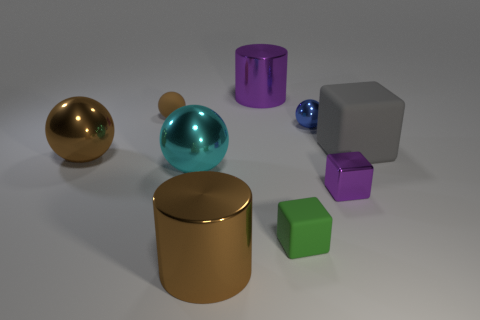Are the big cylinder that is in front of the cyan shiny object and the big cylinder that is on the right side of the brown cylinder made of the same material?
Offer a terse response. Yes. Is there anything else of the same color as the big matte thing?
Provide a succinct answer. No. There is another tiny thing that is the same shape as the blue metal object; what is its color?
Provide a succinct answer. Brown. There is a sphere that is to the left of the tiny blue ball and to the right of the rubber sphere; how big is it?
Offer a very short reply. Large. There is a brown metal thing in front of the tiny green object; is it the same shape as the large thing that is right of the tiny green object?
Your response must be concise. No. There is a large metallic thing that is the same color as the metallic block; what is its shape?
Provide a succinct answer. Cylinder. What number of brown balls have the same material as the purple cylinder?
Offer a very short reply. 1. What shape is the metal object that is both to the right of the large purple metallic thing and to the left of the small metal block?
Keep it short and to the point. Sphere. Does the large thing right of the small purple thing have the same material as the small green cube?
Offer a terse response. Yes. Are there any other things that are made of the same material as the green thing?
Offer a terse response. Yes. 